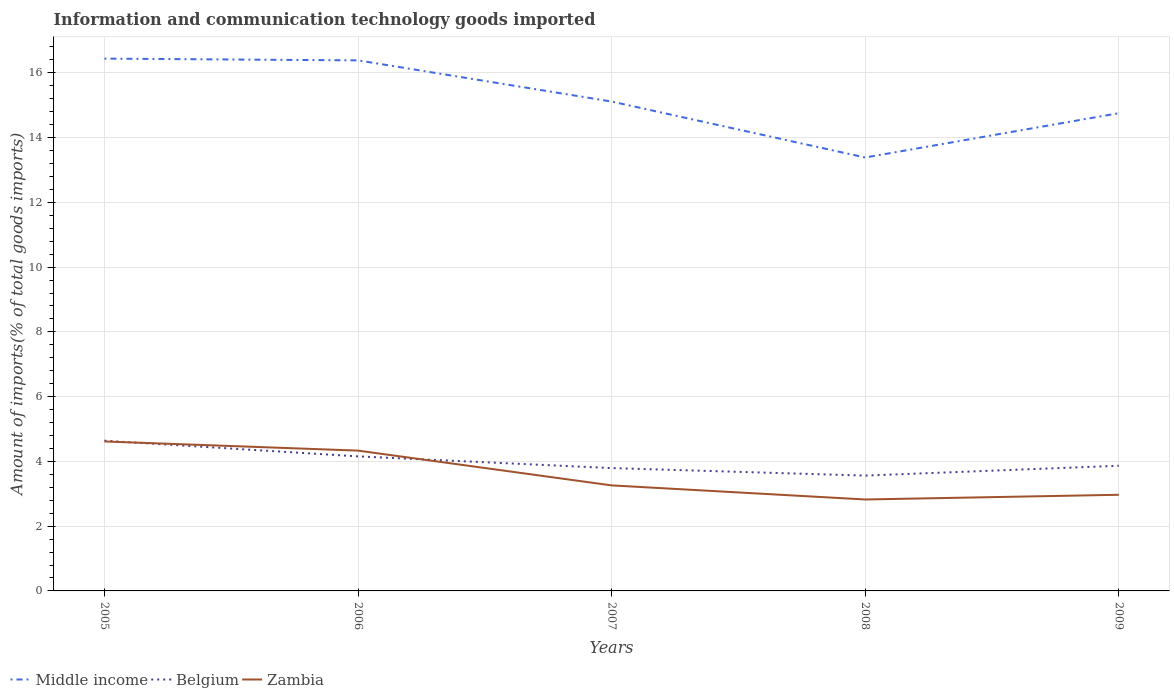Does the line corresponding to Zambia intersect with the line corresponding to Middle income?
Provide a short and direct response. No. Is the number of lines equal to the number of legend labels?
Your answer should be compact. Yes. Across all years, what is the maximum amount of goods imported in Zambia?
Keep it short and to the point. 2.82. What is the total amount of goods imported in Zambia in the graph?
Ensure brevity in your answer.  0.29. What is the difference between the highest and the second highest amount of goods imported in Zambia?
Provide a short and direct response. 1.79. How many lines are there?
Make the answer very short. 3. How many years are there in the graph?
Provide a succinct answer. 5. What is the difference between two consecutive major ticks on the Y-axis?
Give a very brief answer. 2. Does the graph contain grids?
Give a very brief answer. Yes. How many legend labels are there?
Provide a short and direct response. 3. What is the title of the graph?
Your answer should be very brief. Information and communication technology goods imported. What is the label or title of the X-axis?
Your answer should be compact. Years. What is the label or title of the Y-axis?
Ensure brevity in your answer.  Amount of imports(% of total goods imports). What is the Amount of imports(% of total goods imports) of Middle income in 2005?
Offer a terse response. 16.44. What is the Amount of imports(% of total goods imports) in Belgium in 2005?
Provide a succinct answer. 4.64. What is the Amount of imports(% of total goods imports) in Zambia in 2005?
Ensure brevity in your answer.  4.62. What is the Amount of imports(% of total goods imports) in Middle income in 2006?
Offer a terse response. 16.38. What is the Amount of imports(% of total goods imports) in Belgium in 2006?
Offer a very short reply. 4.15. What is the Amount of imports(% of total goods imports) in Zambia in 2006?
Give a very brief answer. 4.33. What is the Amount of imports(% of total goods imports) in Middle income in 2007?
Provide a short and direct response. 15.11. What is the Amount of imports(% of total goods imports) in Belgium in 2007?
Make the answer very short. 3.79. What is the Amount of imports(% of total goods imports) of Zambia in 2007?
Ensure brevity in your answer.  3.26. What is the Amount of imports(% of total goods imports) of Middle income in 2008?
Keep it short and to the point. 13.38. What is the Amount of imports(% of total goods imports) of Belgium in 2008?
Ensure brevity in your answer.  3.56. What is the Amount of imports(% of total goods imports) in Zambia in 2008?
Give a very brief answer. 2.82. What is the Amount of imports(% of total goods imports) of Middle income in 2009?
Keep it short and to the point. 14.75. What is the Amount of imports(% of total goods imports) in Belgium in 2009?
Give a very brief answer. 3.87. What is the Amount of imports(% of total goods imports) of Zambia in 2009?
Provide a succinct answer. 2.97. Across all years, what is the maximum Amount of imports(% of total goods imports) in Middle income?
Keep it short and to the point. 16.44. Across all years, what is the maximum Amount of imports(% of total goods imports) in Belgium?
Provide a succinct answer. 4.64. Across all years, what is the maximum Amount of imports(% of total goods imports) of Zambia?
Provide a short and direct response. 4.62. Across all years, what is the minimum Amount of imports(% of total goods imports) of Middle income?
Your answer should be very brief. 13.38. Across all years, what is the minimum Amount of imports(% of total goods imports) of Belgium?
Make the answer very short. 3.56. Across all years, what is the minimum Amount of imports(% of total goods imports) of Zambia?
Your answer should be very brief. 2.82. What is the total Amount of imports(% of total goods imports) of Middle income in the graph?
Keep it short and to the point. 76.07. What is the total Amount of imports(% of total goods imports) of Belgium in the graph?
Offer a very short reply. 20.01. What is the total Amount of imports(% of total goods imports) in Zambia in the graph?
Your answer should be very brief. 18. What is the difference between the Amount of imports(% of total goods imports) of Middle income in 2005 and that in 2006?
Offer a terse response. 0.05. What is the difference between the Amount of imports(% of total goods imports) of Belgium in 2005 and that in 2006?
Provide a short and direct response. 0.48. What is the difference between the Amount of imports(% of total goods imports) of Zambia in 2005 and that in 2006?
Ensure brevity in your answer.  0.28. What is the difference between the Amount of imports(% of total goods imports) in Middle income in 2005 and that in 2007?
Offer a terse response. 1.33. What is the difference between the Amount of imports(% of total goods imports) of Belgium in 2005 and that in 2007?
Keep it short and to the point. 0.85. What is the difference between the Amount of imports(% of total goods imports) in Zambia in 2005 and that in 2007?
Give a very brief answer. 1.36. What is the difference between the Amount of imports(% of total goods imports) of Middle income in 2005 and that in 2008?
Provide a succinct answer. 3.05. What is the difference between the Amount of imports(% of total goods imports) in Belgium in 2005 and that in 2008?
Your answer should be very brief. 1.08. What is the difference between the Amount of imports(% of total goods imports) of Zambia in 2005 and that in 2008?
Provide a succinct answer. 1.79. What is the difference between the Amount of imports(% of total goods imports) of Middle income in 2005 and that in 2009?
Give a very brief answer. 1.69. What is the difference between the Amount of imports(% of total goods imports) of Belgium in 2005 and that in 2009?
Provide a succinct answer. 0.77. What is the difference between the Amount of imports(% of total goods imports) of Zambia in 2005 and that in 2009?
Your answer should be very brief. 1.65. What is the difference between the Amount of imports(% of total goods imports) in Middle income in 2006 and that in 2007?
Provide a short and direct response. 1.27. What is the difference between the Amount of imports(% of total goods imports) in Belgium in 2006 and that in 2007?
Make the answer very short. 0.36. What is the difference between the Amount of imports(% of total goods imports) of Zambia in 2006 and that in 2007?
Your answer should be compact. 1.07. What is the difference between the Amount of imports(% of total goods imports) of Middle income in 2006 and that in 2008?
Offer a terse response. 3. What is the difference between the Amount of imports(% of total goods imports) of Belgium in 2006 and that in 2008?
Offer a terse response. 0.59. What is the difference between the Amount of imports(% of total goods imports) of Zambia in 2006 and that in 2008?
Offer a terse response. 1.51. What is the difference between the Amount of imports(% of total goods imports) of Middle income in 2006 and that in 2009?
Ensure brevity in your answer.  1.63. What is the difference between the Amount of imports(% of total goods imports) in Belgium in 2006 and that in 2009?
Provide a short and direct response. 0.29. What is the difference between the Amount of imports(% of total goods imports) of Zambia in 2006 and that in 2009?
Provide a succinct answer. 1.36. What is the difference between the Amount of imports(% of total goods imports) of Middle income in 2007 and that in 2008?
Keep it short and to the point. 1.73. What is the difference between the Amount of imports(% of total goods imports) in Belgium in 2007 and that in 2008?
Keep it short and to the point. 0.23. What is the difference between the Amount of imports(% of total goods imports) in Zambia in 2007 and that in 2008?
Your answer should be compact. 0.44. What is the difference between the Amount of imports(% of total goods imports) of Middle income in 2007 and that in 2009?
Your answer should be compact. 0.36. What is the difference between the Amount of imports(% of total goods imports) of Belgium in 2007 and that in 2009?
Ensure brevity in your answer.  -0.07. What is the difference between the Amount of imports(% of total goods imports) in Zambia in 2007 and that in 2009?
Keep it short and to the point. 0.29. What is the difference between the Amount of imports(% of total goods imports) in Middle income in 2008 and that in 2009?
Your answer should be compact. -1.37. What is the difference between the Amount of imports(% of total goods imports) of Belgium in 2008 and that in 2009?
Provide a succinct answer. -0.3. What is the difference between the Amount of imports(% of total goods imports) in Zambia in 2008 and that in 2009?
Keep it short and to the point. -0.15. What is the difference between the Amount of imports(% of total goods imports) in Middle income in 2005 and the Amount of imports(% of total goods imports) in Belgium in 2006?
Give a very brief answer. 12.28. What is the difference between the Amount of imports(% of total goods imports) in Middle income in 2005 and the Amount of imports(% of total goods imports) in Zambia in 2006?
Ensure brevity in your answer.  12.11. What is the difference between the Amount of imports(% of total goods imports) in Belgium in 2005 and the Amount of imports(% of total goods imports) in Zambia in 2006?
Give a very brief answer. 0.31. What is the difference between the Amount of imports(% of total goods imports) of Middle income in 2005 and the Amount of imports(% of total goods imports) of Belgium in 2007?
Offer a very short reply. 12.64. What is the difference between the Amount of imports(% of total goods imports) in Middle income in 2005 and the Amount of imports(% of total goods imports) in Zambia in 2007?
Your answer should be very brief. 13.18. What is the difference between the Amount of imports(% of total goods imports) in Belgium in 2005 and the Amount of imports(% of total goods imports) in Zambia in 2007?
Provide a succinct answer. 1.38. What is the difference between the Amount of imports(% of total goods imports) in Middle income in 2005 and the Amount of imports(% of total goods imports) in Belgium in 2008?
Your answer should be compact. 12.88. What is the difference between the Amount of imports(% of total goods imports) in Middle income in 2005 and the Amount of imports(% of total goods imports) in Zambia in 2008?
Give a very brief answer. 13.61. What is the difference between the Amount of imports(% of total goods imports) in Belgium in 2005 and the Amount of imports(% of total goods imports) in Zambia in 2008?
Your answer should be compact. 1.82. What is the difference between the Amount of imports(% of total goods imports) of Middle income in 2005 and the Amount of imports(% of total goods imports) of Belgium in 2009?
Your answer should be compact. 12.57. What is the difference between the Amount of imports(% of total goods imports) of Middle income in 2005 and the Amount of imports(% of total goods imports) of Zambia in 2009?
Provide a succinct answer. 13.47. What is the difference between the Amount of imports(% of total goods imports) of Belgium in 2005 and the Amount of imports(% of total goods imports) of Zambia in 2009?
Keep it short and to the point. 1.67. What is the difference between the Amount of imports(% of total goods imports) of Middle income in 2006 and the Amount of imports(% of total goods imports) of Belgium in 2007?
Offer a terse response. 12.59. What is the difference between the Amount of imports(% of total goods imports) in Middle income in 2006 and the Amount of imports(% of total goods imports) in Zambia in 2007?
Give a very brief answer. 13.13. What is the difference between the Amount of imports(% of total goods imports) in Belgium in 2006 and the Amount of imports(% of total goods imports) in Zambia in 2007?
Make the answer very short. 0.9. What is the difference between the Amount of imports(% of total goods imports) of Middle income in 2006 and the Amount of imports(% of total goods imports) of Belgium in 2008?
Offer a very short reply. 12.82. What is the difference between the Amount of imports(% of total goods imports) of Middle income in 2006 and the Amount of imports(% of total goods imports) of Zambia in 2008?
Your response must be concise. 13.56. What is the difference between the Amount of imports(% of total goods imports) of Belgium in 2006 and the Amount of imports(% of total goods imports) of Zambia in 2008?
Offer a very short reply. 1.33. What is the difference between the Amount of imports(% of total goods imports) in Middle income in 2006 and the Amount of imports(% of total goods imports) in Belgium in 2009?
Your answer should be compact. 12.52. What is the difference between the Amount of imports(% of total goods imports) in Middle income in 2006 and the Amount of imports(% of total goods imports) in Zambia in 2009?
Ensure brevity in your answer.  13.42. What is the difference between the Amount of imports(% of total goods imports) in Belgium in 2006 and the Amount of imports(% of total goods imports) in Zambia in 2009?
Your answer should be compact. 1.19. What is the difference between the Amount of imports(% of total goods imports) of Middle income in 2007 and the Amount of imports(% of total goods imports) of Belgium in 2008?
Provide a succinct answer. 11.55. What is the difference between the Amount of imports(% of total goods imports) in Middle income in 2007 and the Amount of imports(% of total goods imports) in Zambia in 2008?
Provide a succinct answer. 12.29. What is the difference between the Amount of imports(% of total goods imports) of Belgium in 2007 and the Amount of imports(% of total goods imports) of Zambia in 2008?
Give a very brief answer. 0.97. What is the difference between the Amount of imports(% of total goods imports) in Middle income in 2007 and the Amount of imports(% of total goods imports) in Belgium in 2009?
Provide a short and direct response. 11.25. What is the difference between the Amount of imports(% of total goods imports) in Middle income in 2007 and the Amount of imports(% of total goods imports) in Zambia in 2009?
Provide a succinct answer. 12.14. What is the difference between the Amount of imports(% of total goods imports) in Belgium in 2007 and the Amount of imports(% of total goods imports) in Zambia in 2009?
Make the answer very short. 0.82. What is the difference between the Amount of imports(% of total goods imports) in Middle income in 2008 and the Amount of imports(% of total goods imports) in Belgium in 2009?
Your answer should be very brief. 9.52. What is the difference between the Amount of imports(% of total goods imports) in Middle income in 2008 and the Amount of imports(% of total goods imports) in Zambia in 2009?
Make the answer very short. 10.42. What is the difference between the Amount of imports(% of total goods imports) of Belgium in 2008 and the Amount of imports(% of total goods imports) of Zambia in 2009?
Offer a very short reply. 0.59. What is the average Amount of imports(% of total goods imports) in Middle income per year?
Make the answer very short. 15.21. What is the average Amount of imports(% of total goods imports) in Belgium per year?
Provide a short and direct response. 4. What is the average Amount of imports(% of total goods imports) of Zambia per year?
Provide a short and direct response. 3.6. In the year 2005, what is the difference between the Amount of imports(% of total goods imports) of Middle income and Amount of imports(% of total goods imports) of Belgium?
Offer a terse response. 11.8. In the year 2005, what is the difference between the Amount of imports(% of total goods imports) in Middle income and Amount of imports(% of total goods imports) in Zambia?
Ensure brevity in your answer.  11.82. In the year 2005, what is the difference between the Amount of imports(% of total goods imports) of Belgium and Amount of imports(% of total goods imports) of Zambia?
Offer a terse response. 0.02. In the year 2006, what is the difference between the Amount of imports(% of total goods imports) of Middle income and Amount of imports(% of total goods imports) of Belgium?
Provide a succinct answer. 12.23. In the year 2006, what is the difference between the Amount of imports(% of total goods imports) in Middle income and Amount of imports(% of total goods imports) in Zambia?
Offer a very short reply. 12.05. In the year 2006, what is the difference between the Amount of imports(% of total goods imports) in Belgium and Amount of imports(% of total goods imports) in Zambia?
Provide a succinct answer. -0.18. In the year 2007, what is the difference between the Amount of imports(% of total goods imports) of Middle income and Amount of imports(% of total goods imports) of Belgium?
Your response must be concise. 11.32. In the year 2007, what is the difference between the Amount of imports(% of total goods imports) in Middle income and Amount of imports(% of total goods imports) in Zambia?
Make the answer very short. 11.85. In the year 2007, what is the difference between the Amount of imports(% of total goods imports) in Belgium and Amount of imports(% of total goods imports) in Zambia?
Give a very brief answer. 0.53. In the year 2008, what is the difference between the Amount of imports(% of total goods imports) of Middle income and Amount of imports(% of total goods imports) of Belgium?
Your answer should be compact. 9.82. In the year 2008, what is the difference between the Amount of imports(% of total goods imports) in Middle income and Amount of imports(% of total goods imports) in Zambia?
Offer a terse response. 10.56. In the year 2008, what is the difference between the Amount of imports(% of total goods imports) of Belgium and Amount of imports(% of total goods imports) of Zambia?
Ensure brevity in your answer.  0.74. In the year 2009, what is the difference between the Amount of imports(% of total goods imports) of Middle income and Amount of imports(% of total goods imports) of Belgium?
Provide a succinct answer. 10.89. In the year 2009, what is the difference between the Amount of imports(% of total goods imports) of Middle income and Amount of imports(% of total goods imports) of Zambia?
Provide a succinct answer. 11.78. In the year 2009, what is the difference between the Amount of imports(% of total goods imports) of Belgium and Amount of imports(% of total goods imports) of Zambia?
Your response must be concise. 0.9. What is the ratio of the Amount of imports(% of total goods imports) of Belgium in 2005 to that in 2006?
Keep it short and to the point. 1.12. What is the ratio of the Amount of imports(% of total goods imports) in Zambia in 2005 to that in 2006?
Offer a very short reply. 1.07. What is the ratio of the Amount of imports(% of total goods imports) of Middle income in 2005 to that in 2007?
Your answer should be very brief. 1.09. What is the ratio of the Amount of imports(% of total goods imports) of Belgium in 2005 to that in 2007?
Your answer should be very brief. 1.22. What is the ratio of the Amount of imports(% of total goods imports) in Zambia in 2005 to that in 2007?
Provide a succinct answer. 1.42. What is the ratio of the Amount of imports(% of total goods imports) in Middle income in 2005 to that in 2008?
Your answer should be compact. 1.23. What is the ratio of the Amount of imports(% of total goods imports) of Belgium in 2005 to that in 2008?
Make the answer very short. 1.3. What is the ratio of the Amount of imports(% of total goods imports) of Zambia in 2005 to that in 2008?
Your response must be concise. 1.63. What is the ratio of the Amount of imports(% of total goods imports) in Middle income in 2005 to that in 2009?
Make the answer very short. 1.11. What is the ratio of the Amount of imports(% of total goods imports) of Belgium in 2005 to that in 2009?
Your response must be concise. 1.2. What is the ratio of the Amount of imports(% of total goods imports) in Zambia in 2005 to that in 2009?
Provide a short and direct response. 1.55. What is the ratio of the Amount of imports(% of total goods imports) of Middle income in 2006 to that in 2007?
Provide a short and direct response. 1.08. What is the ratio of the Amount of imports(% of total goods imports) in Belgium in 2006 to that in 2007?
Keep it short and to the point. 1.1. What is the ratio of the Amount of imports(% of total goods imports) in Zambia in 2006 to that in 2007?
Provide a succinct answer. 1.33. What is the ratio of the Amount of imports(% of total goods imports) in Middle income in 2006 to that in 2008?
Your answer should be very brief. 1.22. What is the ratio of the Amount of imports(% of total goods imports) in Belgium in 2006 to that in 2008?
Provide a succinct answer. 1.17. What is the ratio of the Amount of imports(% of total goods imports) in Zambia in 2006 to that in 2008?
Your answer should be compact. 1.53. What is the ratio of the Amount of imports(% of total goods imports) in Middle income in 2006 to that in 2009?
Provide a succinct answer. 1.11. What is the ratio of the Amount of imports(% of total goods imports) of Belgium in 2006 to that in 2009?
Give a very brief answer. 1.07. What is the ratio of the Amount of imports(% of total goods imports) in Zambia in 2006 to that in 2009?
Your response must be concise. 1.46. What is the ratio of the Amount of imports(% of total goods imports) of Middle income in 2007 to that in 2008?
Offer a terse response. 1.13. What is the ratio of the Amount of imports(% of total goods imports) of Belgium in 2007 to that in 2008?
Your response must be concise. 1.07. What is the ratio of the Amount of imports(% of total goods imports) in Zambia in 2007 to that in 2008?
Your answer should be very brief. 1.15. What is the ratio of the Amount of imports(% of total goods imports) in Middle income in 2007 to that in 2009?
Offer a very short reply. 1.02. What is the ratio of the Amount of imports(% of total goods imports) in Belgium in 2007 to that in 2009?
Keep it short and to the point. 0.98. What is the ratio of the Amount of imports(% of total goods imports) of Zambia in 2007 to that in 2009?
Your response must be concise. 1.1. What is the ratio of the Amount of imports(% of total goods imports) of Middle income in 2008 to that in 2009?
Offer a very short reply. 0.91. What is the ratio of the Amount of imports(% of total goods imports) in Belgium in 2008 to that in 2009?
Your response must be concise. 0.92. What is the ratio of the Amount of imports(% of total goods imports) in Zambia in 2008 to that in 2009?
Your answer should be compact. 0.95. What is the difference between the highest and the second highest Amount of imports(% of total goods imports) of Middle income?
Provide a succinct answer. 0.05. What is the difference between the highest and the second highest Amount of imports(% of total goods imports) of Belgium?
Offer a terse response. 0.48. What is the difference between the highest and the second highest Amount of imports(% of total goods imports) in Zambia?
Your response must be concise. 0.28. What is the difference between the highest and the lowest Amount of imports(% of total goods imports) in Middle income?
Your answer should be very brief. 3.05. What is the difference between the highest and the lowest Amount of imports(% of total goods imports) of Belgium?
Ensure brevity in your answer.  1.08. What is the difference between the highest and the lowest Amount of imports(% of total goods imports) in Zambia?
Provide a short and direct response. 1.79. 